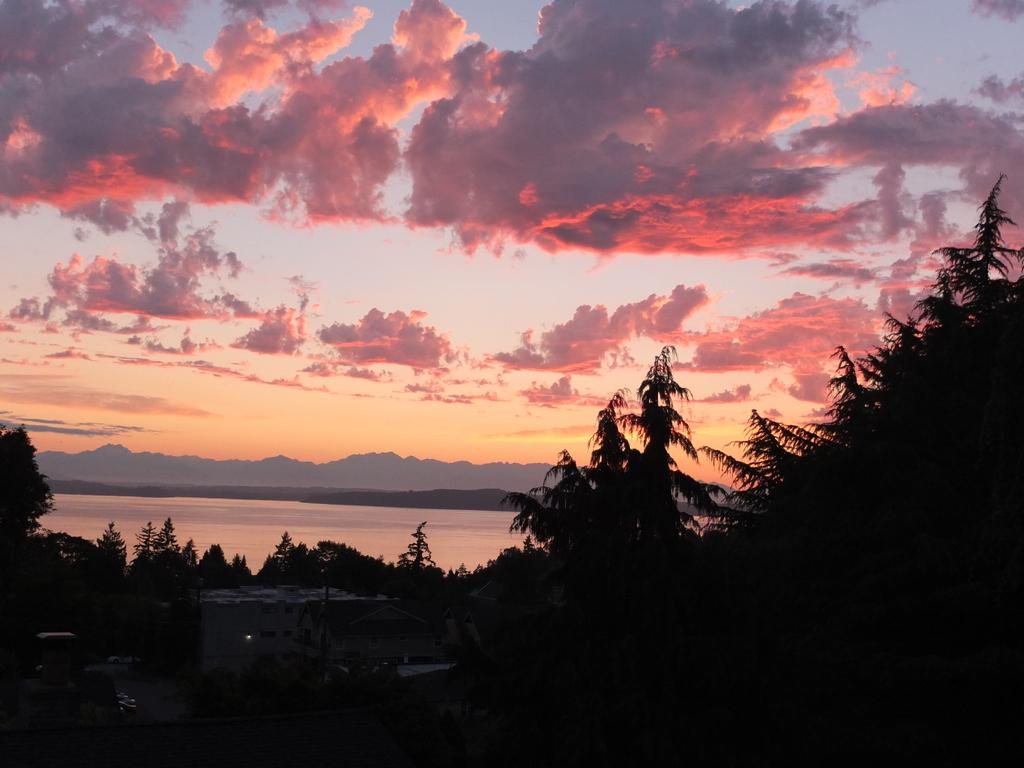What type of natural environment is depicted in the image? The image contains trees, water, mountains, and sky, suggesting a natural landscape. Can you describe the water in the image? There is water visible in the image, but its specific characteristics are not mentioned in the facts. What type of objects can be seen in the image? The facts mention that there are objects in the image, but their nature is not specified. What is visible in the background of the image? The sky is visible in the background of the image, and clouds are present in the sky. What year is depicted in the image? The image does not depict a specific year; it is a year is not a visual element that can be seen in the image. 